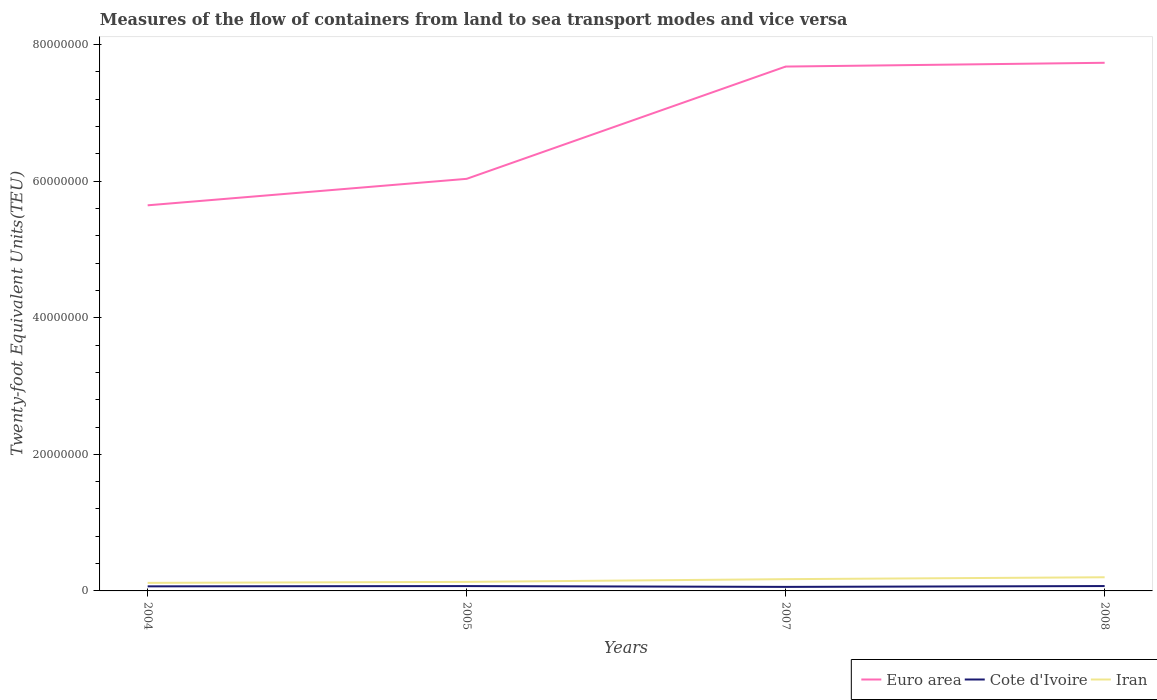Across all years, what is the maximum container port traffic in Iran?
Provide a short and direct response. 1.18e+06. What is the total container port traffic in Iran in the graph?
Provide a succinct answer. -6.75e+05. What is the difference between the highest and the second highest container port traffic in Euro area?
Your response must be concise. 2.09e+07. What is the difference between two consecutive major ticks on the Y-axis?
Offer a very short reply. 2.00e+07. Does the graph contain any zero values?
Your answer should be very brief. No. How are the legend labels stacked?
Offer a very short reply. Horizontal. What is the title of the graph?
Your response must be concise. Measures of the flow of containers from land to sea transport modes and vice versa. What is the label or title of the X-axis?
Ensure brevity in your answer.  Years. What is the label or title of the Y-axis?
Offer a very short reply. Twenty-foot Equivalent Units(TEU). What is the Twenty-foot Equivalent Units(TEU) of Euro area in 2004?
Give a very brief answer. 5.65e+07. What is the Twenty-foot Equivalent Units(TEU) of Cote d'Ivoire in 2004?
Your answer should be very brief. 6.70e+05. What is the Twenty-foot Equivalent Units(TEU) of Iran in 2004?
Your answer should be compact. 1.18e+06. What is the Twenty-foot Equivalent Units(TEU) in Euro area in 2005?
Offer a terse response. 6.03e+07. What is the Twenty-foot Equivalent Units(TEU) in Cote d'Ivoire in 2005?
Your answer should be compact. 7.10e+05. What is the Twenty-foot Equivalent Units(TEU) in Iran in 2005?
Your response must be concise. 1.33e+06. What is the Twenty-foot Equivalent Units(TEU) in Euro area in 2007?
Provide a short and direct response. 7.68e+07. What is the Twenty-foot Equivalent Units(TEU) in Cote d'Ivoire in 2007?
Your answer should be compact. 5.90e+05. What is the Twenty-foot Equivalent Units(TEU) in Iran in 2007?
Offer a terse response. 1.72e+06. What is the Twenty-foot Equivalent Units(TEU) of Euro area in 2008?
Provide a succinct answer. 7.73e+07. What is the Twenty-foot Equivalent Units(TEU) in Cote d'Ivoire in 2008?
Make the answer very short. 7.14e+05. What is the Twenty-foot Equivalent Units(TEU) in Iran in 2008?
Keep it short and to the point. 2.00e+06. Across all years, what is the maximum Twenty-foot Equivalent Units(TEU) of Euro area?
Ensure brevity in your answer.  7.73e+07. Across all years, what is the maximum Twenty-foot Equivalent Units(TEU) of Cote d'Ivoire?
Ensure brevity in your answer.  7.14e+05. Across all years, what is the maximum Twenty-foot Equivalent Units(TEU) of Iran?
Give a very brief answer. 2.00e+06. Across all years, what is the minimum Twenty-foot Equivalent Units(TEU) in Euro area?
Your response must be concise. 5.65e+07. Across all years, what is the minimum Twenty-foot Equivalent Units(TEU) of Cote d'Ivoire?
Ensure brevity in your answer.  5.90e+05. Across all years, what is the minimum Twenty-foot Equivalent Units(TEU) of Iran?
Provide a succinct answer. 1.18e+06. What is the total Twenty-foot Equivalent Units(TEU) in Euro area in the graph?
Provide a short and direct response. 2.71e+08. What is the total Twenty-foot Equivalent Units(TEU) in Cote d'Ivoire in the graph?
Your answer should be very brief. 2.68e+06. What is the total Twenty-foot Equivalent Units(TEU) of Iran in the graph?
Give a very brief answer. 6.23e+06. What is the difference between the Twenty-foot Equivalent Units(TEU) of Euro area in 2004 and that in 2005?
Provide a short and direct response. -3.88e+06. What is the difference between the Twenty-foot Equivalent Units(TEU) in Cote d'Ivoire in 2004 and that in 2005?
Your response must be concise. -4.00e+04. What is the difference between the Twenty-foot Equivalent Units(TEU) of Iran in 2004 and that in 2005?
Make the answer very short. -1.48e+05. What is the difference between the Twenty-foot Equivalent Units(TEU) of Euro area in 2004 and that in 2007?
Offer a terse response. -2.03e+07. What is the difference between the Twenty-foot Equivalent Units(TEU) in Cote d'Ivoire in 2004 and that in 2007?
Provide a succinct answer. 7.97e+04. What is the difference between the Twenty-foot Equivalent Units(TEU) in Iran in 2004 and that in 2007?
Your answer should be compact. -5.45e+05. What is the difference between the Twenty-foot Equivalent Units(TEU) in Euro area in 2004 and that in 2008?
Ensure brevity in your answer.  -2.09e+07. What is the difference between the Twenty-foot Equivalent Units(TEU) in Cote d'Ivoire in 2004 and that in 2008?
Make the answer very short. -4.36e+04. What is the difference between the Twenty-foot Equivalent Units(TEU) in Iran in 2004 and that in 2008?
Your response must be concise. -8.23e+05. What is the difference between the Twenty-foot Equivalent Units(TEU) in Euro area in 2005 and that in 2007?
Your response must be concise. -1.64e+07. What is the difference between the Twenty-foot Equivalent Units(TEU) of Cote d'Ivoire in 2005 and that in 2007?
Keep it short and to the point. 1.20e+05. What is the difference between the Twenty-foot Equivalent Units(TEU) of Iran in 2005 and that in 2007?
Make the answer very short. -3.97e+05. What is the difference between the Twenty-foot Equivalent Units(TEU) of Euro area in 2005 and that in 2008?
Offer a terse response. -1.70e+07. What is the difference between the Twenty-foot Equivalent Units(TEU) of Cote d'Ivoire in 2005 and that in 2008?
Ensure brevity in your answer.  -3625. What is the difference between the Twenty-foot Equivalent Units(TEU) in Iran in 2005 and that in 2008?
Give a very brief answer. -6.75e+05. What is the difference between the Twenty-foot Equivalent Units(TEU) of Euro area in 2007 and that in 2008?
Make the answer very short. -5.53e+05. What is the difference between the Twenty-foot Equivalent Units(TEU) of Cote d'Ivoire in 2007 and that in 2008?
Your answer should be very brief. -1.23e+05. What is the difference between the Twenty-foot Equivalent Units(TEU) of Iran in 2007 and that in 2008?
Offer a terse response. -2.78e+05. What is the difference between the Twenty-foot Equivalent Units(TEU) of Euro area in 2004 and the Twenty-foot Equivalent Units(TEU) of Cote d'Ivoire in 2005?
Ensure brevity in your answer.  5.58e+07. What is the difference between the Twenty-foot Equivalent Units(TEU) of Euro area in 2004 and the Twenty-foot Equivalent Units(TEU) of Iran in 2005?
Offer a terse response. 5.51e+07. What is the difference between the Twenty-foot Equivalent Units(TEU) in Cote d'Ivoire in 2004 and the Twenty-foot Equivalent Units(TEU) in Iran in 2005?
Offer a terse response. -6.56e+05. What is the difference between the Twenty-foot Equivalent Units(TEU) of Euro area in 2004 and the Twenty-foot Equivalent Units(TEU) of Cote d'Ivoire in 2007?
Provide a succinct answer. 5.59e+07. What is the difference between the Twenty-foot Equivalent Units(TEU) in Euro area in 2004 and the Twenty-foot Equivalent Units(TEU) in Iran in 2007?
Provide a short and direct response. 5.47e+07. What is the difference between the Twenty-foot Equivalent Units(TEU) in Cote d'Ivoire in 2004 and the Twenty-foot Equivalent Units(TEU) in Iran in 2007?
Give a very brief answer. -1.05e+06. What is the difference between the Twenty-foot Equivalent Units(TEU) of Euro area in 2004 and the Twenty-foot Equivalent Units(TEU) of Cote d'Ivoire in 2008?
Offer a terse response. 5.57e+07. What is the difference between the Twenty-foot Equivalent Units(TEU) in Euro area in 2004 and the Twenty-foot Equivalent Units(TEU) in Iran in 2008?
Make the answer very short. 5.45e+07. What is the difference between the Twenty-foot Equivalent Units(TEU) in Cote d'Ivoire in 2004 and the Twenty-foot Equivalent Units(TEU) in Iran in 2008?
Your response must be concise. -1.33e+06. What is the difference between the Twenty-foot Equivalent Units(TEU) of Euro area in 2005 and the Twenty-foot Equivalent Units(TEU) of Cote d'Ivoire in 2007?
Your answer should be very brief. 5.98e+07. What is the difference between the Twenty-foot Equivalent Units(TEU) of Euro area in 2005 and the Twenty-foot Equivalent Units(TEU) of Iran in 2007?
Provide a short and direct response. 5.86e+07. What is the difference between the Twenty-foot Equivalent Units(TEU) in Cote d'Ivoire in 2005 and the Twenty-foot Equivalent Units(TEU) in Iran in 2007?
Make the answer very short. -1.01e+06. What is the difference between the Twenty-foot Equivalent Units(TEU) in Euro area in 2005 and the Twenty-foot Equivalent Units(TEU) in Cote d'Ivoire in 2008?
Keep it short and to the point. 5.96e+07. What is the difference between the Twenty-foot Equivalent Units(TEU) in Euro area in 2005 and the Twenty-foot Equivalent Units(TEU) in Iran in 2008?
Provide a succinct answer. 5.83e+07. What is the difference between the Twenty-foot Equivalent Units(TEU) in Cote d'Ivoire in 2005 and the Twenty-foot Equivalent Units(TEU) in Iran in 2008?
Keep it short and to the point. -1.29e+06. What is the difference between the Twenty-foot Equivalent Units(TEU) of Euro area in 2007 and the Twenty-foot Equivalent Units(TEU) of Cote d'Ivoire in 2008?
Your answer should be very brief. 7.61e+07. What is the difference between the Twenty-foot Equivalent Units(TEU) in Euro area in 2007 and the Twenty-foot Equivalent Units(TEU) in Iran in 2008?
Make the answer very short. 7.48e+07. What is the difference between the Twenty-foot Equivalent Units(TEU) of Cote d'Ivoire in 2007 and the Twenty-foot Equivalent Units(TEU) of Iran in 2008?
Your answer should be compact. -1.41e+06. What is the average Twenty-foot Equivalent Units(TEU) in Euro area per year?
Provide a succinct answer. 6.77e+07. What is the average Twenty-foot Equivalent Units(TEU) in Cote d'Ivoire per year?
Give a very brief answer. 6.71e+05. What is the average Twenty-foot Equivalent Units(TEU) of Iran per year?
Your answer should be very brief. 1.56e+06. In the year 2004, what is the difference between the Twenty-foot Equivalent Units(TEU) of Euro area and Twenty-foot Equivalent Units(TEU) of Cote d'Ivoire?
Give a very brief answer. 5.58e+07. In the year 2004, what is the difference between the Twenty-foot Equivalent Units(TEU) of Euro area and Twenty-foot Equivalent Units(TEU) of Iran?
Offer a terse response. 5.53e+07. In the year 2004, what is the difference between the Twenty-foot Equivalent Units(TEU) in Cote d'Ivoire and Twenty-foot Equivalent Units(TEU) in Iran?
Give a very brief answer. -5.07e+05. In the year 2005, what is the difference between the Twenty-foot Equivalent Units(TEU) in Euro area and Twenty-foot Equivalent Units(TEU) in Cote d'Ivoire?
Offer a very short reply. 5.96e+07. In the year 2005, what is the difference between the Twenty-foot Equivalent Units(TEU) in Euro area and Twenty-foot Equivalent Units(TEU) in Iran?
Your response must be concise. 5.90e+07. In the year 2005, what is the difference between the Twenty-foot Equivalent Units(TEU) in Cote d'Ivoire and Twenty-foot Equivalent Units(TEU) in Iran?
Your answer should be compact. -6.16e+05. In the year 2007, what is the difference between the Twenty-foot Equivalent Units(TEU) of Euro area and Twenty-foot Equivalent Units(TEU) of Cote d'Ivoire?
Your answer should be compact. 7.62e+07. In the year 2007, what is the difference between the Twenty-foot Equivalent Units(TEU) in Euro area and Twenty-foot Equivalent Units(TEU) in Iran?
Your answer should be compact. 7.51e+07. In the year 2007, what is the difference between the Twenty-foot Equivalent Units(TEU) in Cote d'Ivoire and Twenty-foot Equivalent Units(TEU) in Iran?
Your response must be concise. -1.13e+06. In the year 2008, what is the difference between the Twenty-foot Equivalent Units(TEU) in Euro area and Twenty-foot Equivalent Units(TEU) in Cote d'Ivoire?
Your answer should be very brief. 7.66e+07. In the year 2008, what is the difference between the Twenty-foot Equivalent Units(TEU) in Euro area and Twenty-foot Equivalent Units(TEU) in Iran?
Provide a short and direct response. 7.53e+07. In the year 2008, what is the difference between the Twenty-foot Equivalent Units(TEU) of Cote d'Ivoire and Twenty-foot Equivalent Units(TEU) of Iran?
Your response must be concise. -1.29e+06. What is the ratio of the Twenty-foot Equivalent Units(TEU) in Euro area in 2004 to that in 2005?
Your answer should be compact. 0.94. What is the ratio of the Twenty-foot Equivalent Units(TEU) in Cote d'Ivoire in 2004 to that in 2005?
Offer a very short reply. 0.94. What is the ratio of the Twenty-foot Equivalent Units(TEU) of Iran in 2004 to that in 2005?
Offer a very short reply. 0.89. What is the ratio of the Twenty-foot Equivalent Units(TEU) of Euro area in 2004 to that in 2007?
Provide a succinct answer. 0.74. What is the ratio of the Twenty-foot Equivalent Units(TEU) of Cote d'Ivoire in 2004 to that in 2007?
Ensure brevity in your answer.  1.14. What is the ratio of the Twenty-foot Equivalent Units(TEU) in Iran in 2004 to that in 2007?
Your response must be concise. 0.68. What is the ratio of the Twenty-foot Equivalent Units(TEU) of Euro area in 2004 to that in 2008?
Your response must be concise. 0.73. What is the ratio of the Twenty-foot Equivalent Units(TEU) in Cote d'Ivoire in 2004 to that in 2008?
Your answer should be very brief. 0.94. What is the ratio of the Twenty-foot Equivalent Units(TEU) of Iran in 2004 to that in 2008?
Your response must be concise. 0.59. What is the ratio of the Twenty-foot Equivalent Units(TEU) in Euro area in 2005 to that in 2007?
Keep it short and to the point. 0.79. What is the ratio of the Twenty-foot Equivalent Units(TEU) in Cote d'Ivoire in 2005 to that in 2007?
Make the answer very short. 1.2. What is the ratio of the Twenty-foot Equivalent Units(TEU) of Iran in 2005 to that in 2007?
Your answer should be very brief. 0.77. What is the ratio of the Twenty-foot Equivalent Units(TEU) in Euro area in 2005 to that in 2008?
Keep it short and to the point. 0.78. What is the ratio of the Twenty-foot Equivalent Units(TEU) of Iran in 2005 to that in 2008?
Provide a short and direct response. 0.66. What is the ratio of the Twenty-foot Equivalent Units(TEU) of Euro area in 2007 to that in 2008?
Offer a very short reply. 0.99. What is the ratio of the Twenty-foot Equivalent Units(TEU) of Cote d'Ivoire in 2007 to that in 2008?
Give a very brief answer. 0.83. What is the ratio of the Twenty-foot Equivalent Units(TEU) of Iran in 2007 to that in 2008?
Offer a terse response. 0.86. What is the difference between the highest and the second highest Twenty-foot Equivalent Units(TEU) in Euro area?
Your answer should be compact. 5.53e+05. What is the difference between the highest and the second highest Twenty-foot Equivalent Units(TEU) in Cote d'Ivoire?
Offer a very short reply. 3625. What is the difference between the highest and the second highest Twenty-foot Equivalent Units(TEU) of Iran?
Give a very brief answer. 2.78e+05. What is the difference between the highest and the lowest Twenty-foot Equivalent Units(TEU) of Euro area?
Give a very brief answer. 2.09e+07. What is the difference between the highest and the lowest Twenty-foot Equivalent Units(TEU) in Cote d'Ivoire?
Your response must be concise. 1.23e+05. What is the difference between the highest and the lowest Twenty-foot Equivalent Units(TEU) of Iran?
Give a very brief answer. 8.23e+05. 